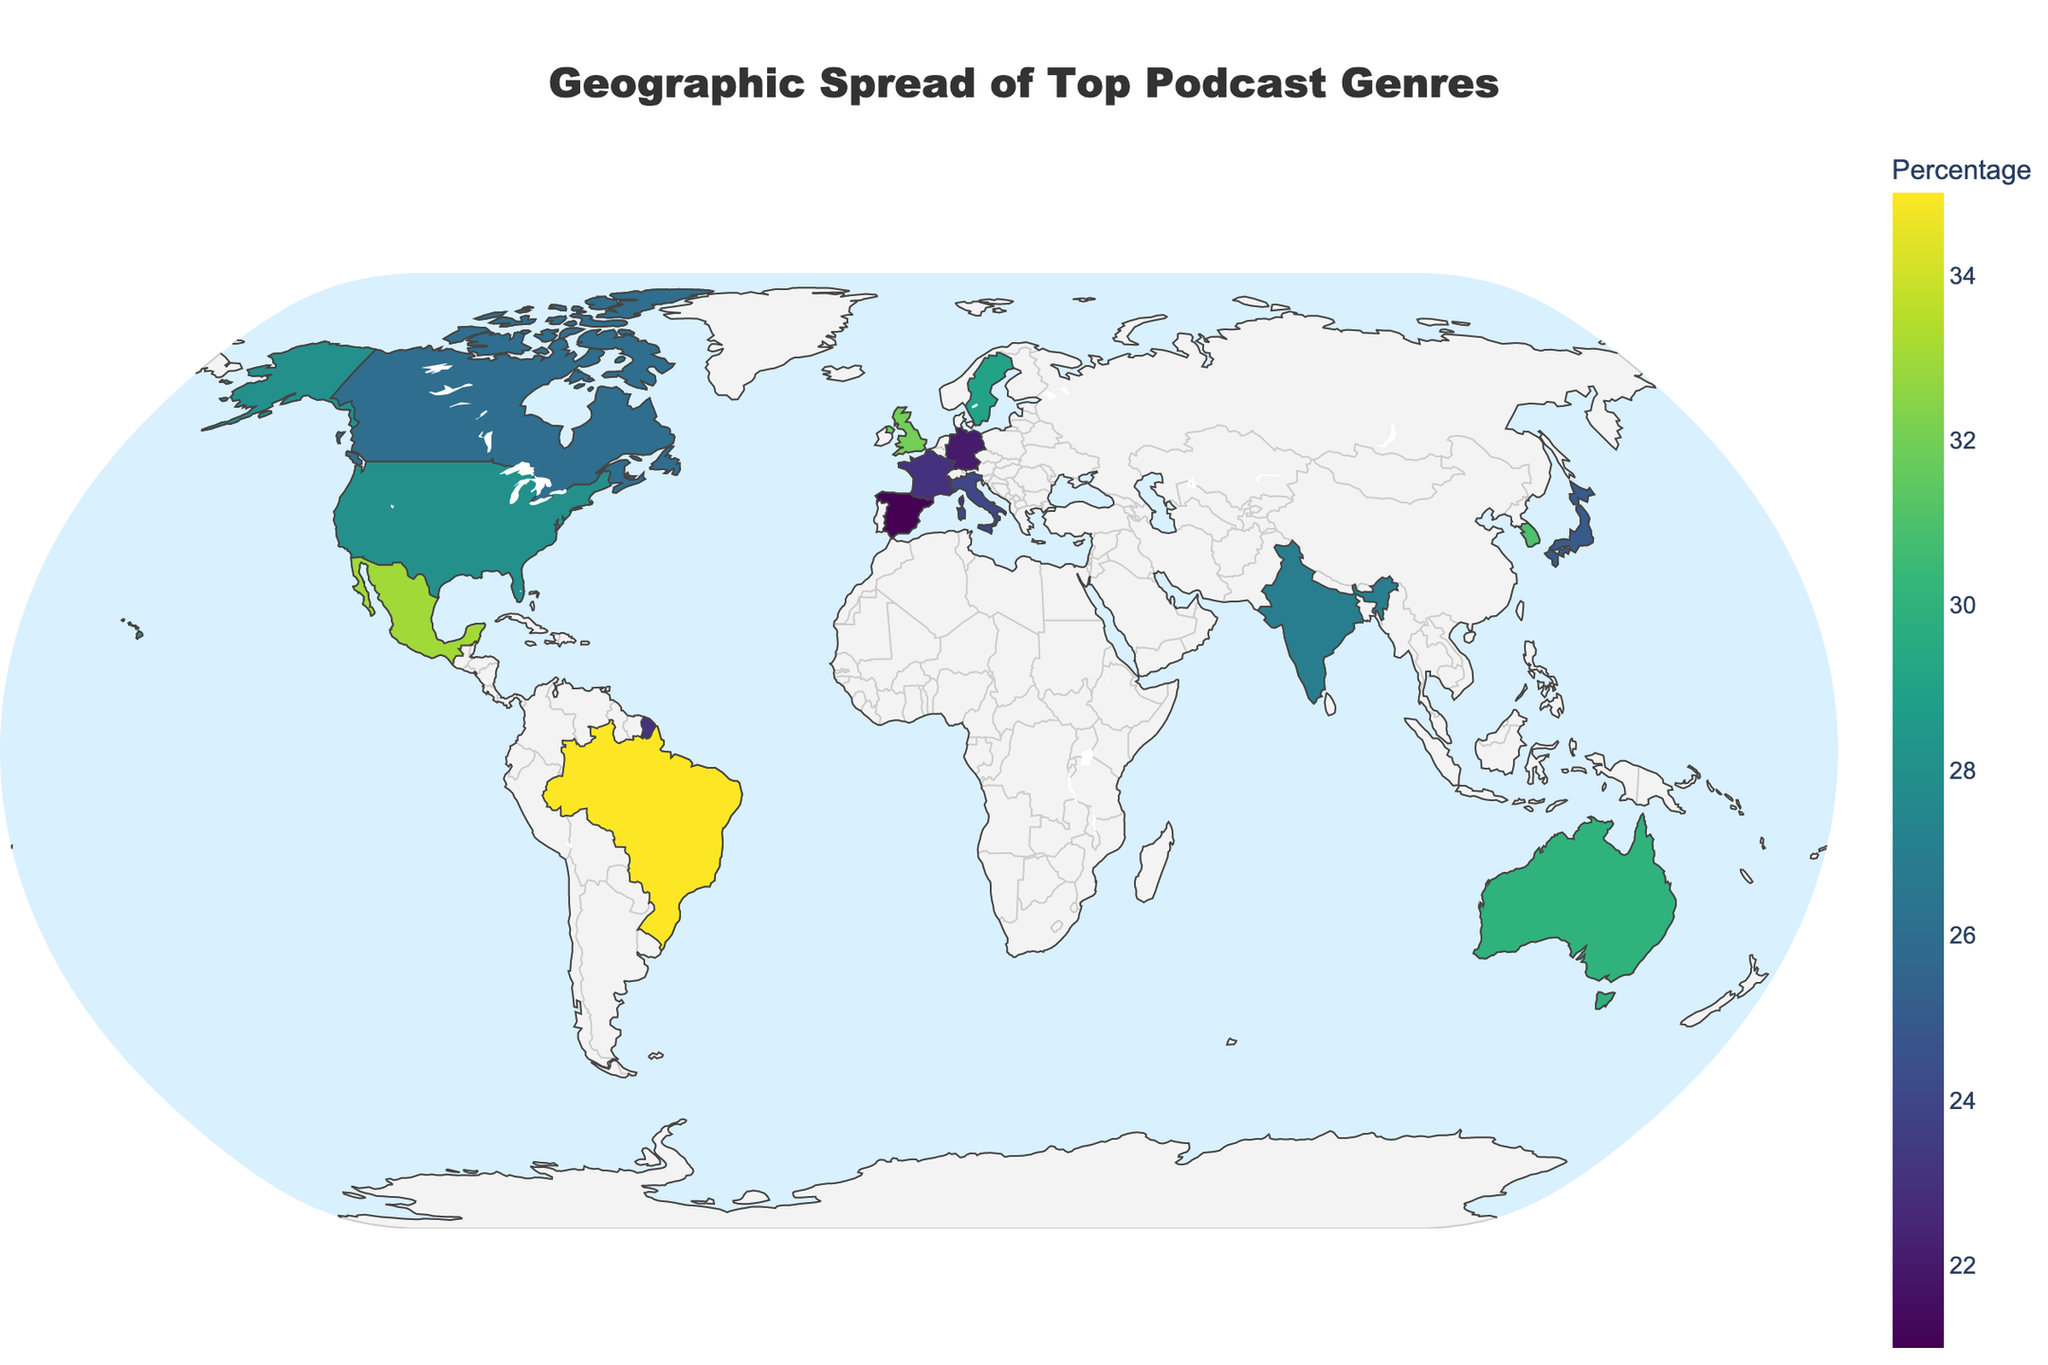What is the top podcast genre in the United States? The figure shows different countries with their respective top podcast genres. For the United States, the top genre is visually indicated.
Answer: True Crime Which country shows the highest percentage of listeners for their top genre, and what is the genre? We need to look at the color intensity or use the hover data to identify the country with the highest percentage. According to the data, Brazil has the highest percentage of listeners for its top podcast genre.
Answer: Brazil, Sports Which countries share a top podcast genre focused on societal themes, and what are those themes? Scan the annotations or hover data for genres related to societal themes like "Society & Culture," "News & Politics," or "Education." The countries sharing these themes are Canada (Society & Culture), Australia (News & Politics), and Germany (Education).
Answer: Canada, Australia, Germany What is the difference in percentage between the top podcast genres of France and Germany? France's top podcast genre percentage is 23%, and Germany's is 22%. Subtract one from the other to find the difference.
Answer: 1% Which country has 'The Joe Rogan Experience' as its most popular show, and what genre does it belong to? Use the hover data or annotation to find the country that features 'The Joe Rogan Experience' as the most popular show. For that country, the top genre is provided.
Answer: United Kingdom, Comedy Between Australia and South Korea, which country has a higher percentage of listeners for its top podcast genre? Australia has 30% for News & Politics, and South Korea has 31% for Health & Fitness. Compare these two values.
Answer: South Korea Identify the countries where the top podcast genre's percentage is over 30%. Look at the legend or hover over the countries to identify those with a percentage greater than 30%. These countries are the United Kingdom (32%), Brazil (35%), South Korea (31%), and Mexico (33%).
Answer: United Kingdom, Brazil, South Korea, Mexico What is the most popular show in Japan, and what percentage of listeners does the top podcast genre have? Refer to the annotation or hover data for Japan. The top show is 'Rebuild,' and the genre's percentage is 25%.
Answer: Rebuild, 25% Compare the top podcast genres of Spain and Italy. What are the genres, and which one has a higher listener percentage? Spain's top genre is Science with 21%, and Italy's top genre is History with 24%. Compare the percentages to determine the higher one.
Answer: Italy, History, 24% 